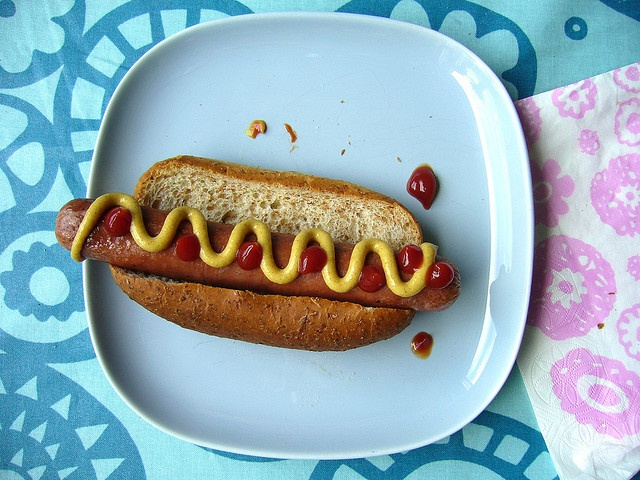Describe the objects in this image and their specific colors. I can see a hot dog in teal, maroon, brown, black, and khaki tones in this image. 